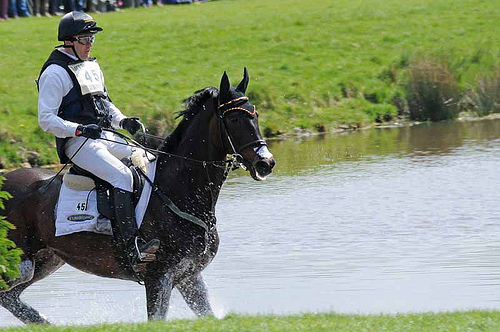Describe the background scene in the image. The background scene in the image shows a peaceful and serene natural environment with a grassy field and a small body of water. There are some trees and bushes in the distance, adding to the tranquil setting. What might the man be doing at this moment? The man appears to be participating in an equestrian event, possibly a cross-country or show jumping competition, as he is riding a horse through a water obstacle. Imagine a scenario where the horse transforms into a mythical creature. What might happen next? If the horse transformed into a mythical creature, such as a Pegasus, the scene might become quite spectacular. The man could find himself soaring through the sky, flying over the pristine pastures and sparkling lakes, with the Pegasus's wings beating gracefully. This transformation would undoubtedly amaze onlookers and add an enchanting element to the competition. What can be inferred about the level of skill of the rider? The rider appears to be highly skilled, given his confident posture and precise control over the horse as it navigates through the water obstacle. This level of control suggests experience and expertise in equestrian sports. 